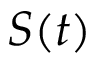Convert formula to latex. <formula><loc_0><loc_0><loc_500><loc_500>S ( t )</formula> 